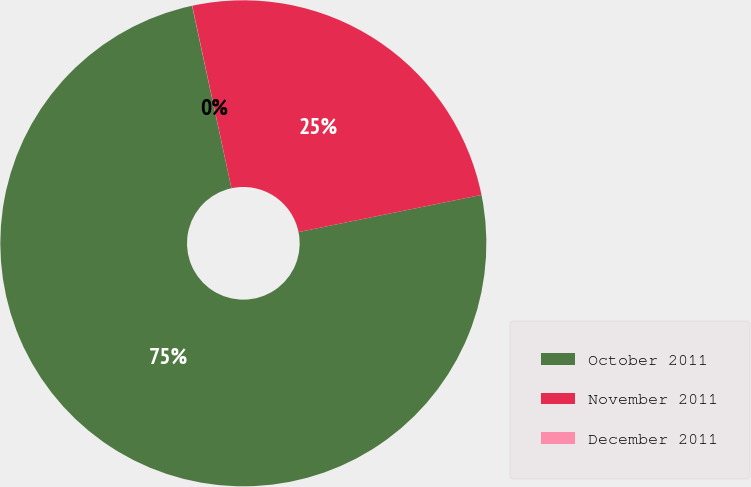Convert chart. <chart><loc_0><loc_0><loc_500><loc_500><pie_chart><fcel>October 2011<fcel>November 2011<fcel>December 2011<nl><fcel>74.81%<fcel>25.18%<fcel>0.01%<nl></chart> 